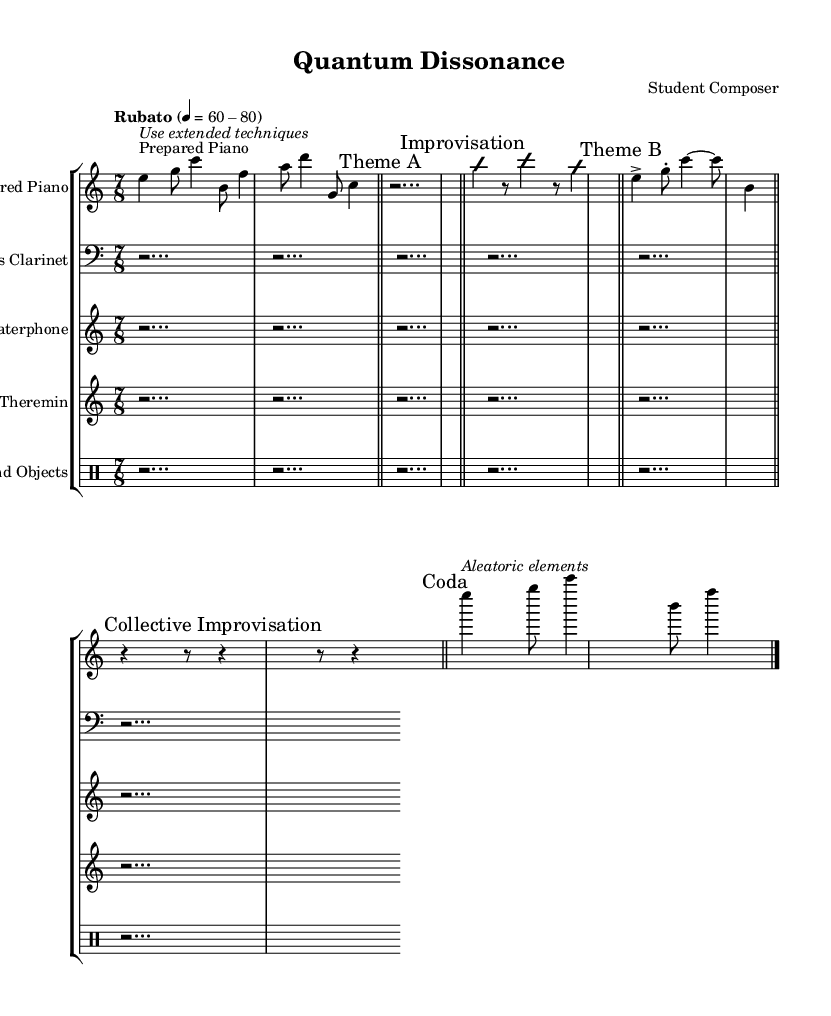What is the time signature of this music? The time signature is indicated at the beginning of the score as 7/8, which shows that there are seven eighth notes in each measure.
Answer: 7/8 What is the tempo marking for this piece? The tempo marking is placed at the beginning of the score and indicated as "Rubato" with a range of 60-80 beats per minute. This suggests a flexible tempo.
Answer: Rubato, 60-80 How many distinct sections are marked in this sheet music? In the sheet music, several sections are explicitly marked: Theme A, Improvisation, Theme B, Collective Improvisation, and Coda. Counting these labels gives us five distinct sections.
Answer: 5 What type of instruments are used in this composition? The instruments presented in the score include Prepared Piano, Contrabass Clarinet, Waterphone, Theremin, and Found Objects. These are specified at the start of each staff.
Answer: Prepared Piano, Contrabass Clarinet, Waterphone, Theremin, Found Objects What does the term "improvisation" signify in this piece? The term "improvisation" appears twice in the music, suggesting passages where the musicians are allowed to create spontaneous melodies or harmonies, deviating from the written notes during those sections.
Answer: Spontaneous melodies or harmonies Which section suggests the use of aleatoric elements? The section marked "Coda" indicates the use of aleatoric elements with a notation specifically mentioning it, signaling a lack of strict organizational structure in that part.
Answer: Coda What is indicated by the phrase "Use extended techniques" in this composition? The phrase appears in the context of prepared piano, suggesting that the performer should employ unconventional playing techniques that go beyond traditional methods, to explore new sound textures.
Answer: Extended techniques 